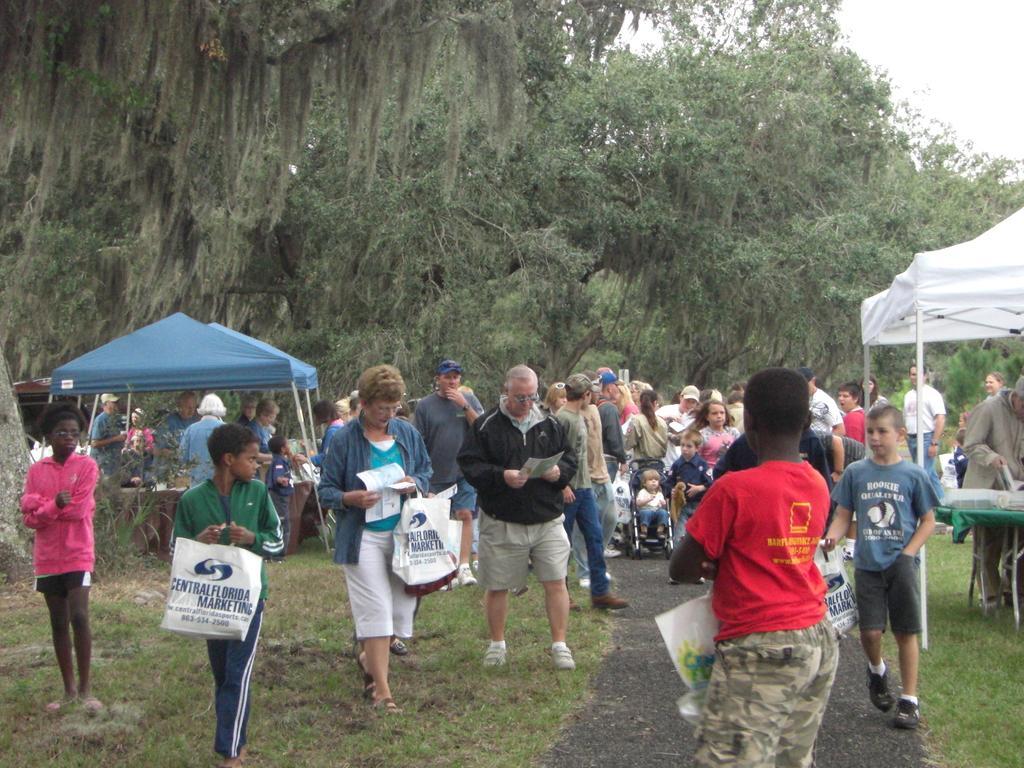Please provide a concise description of this image. There are people holding carry bags. There are trees and umbrellas at the back. 